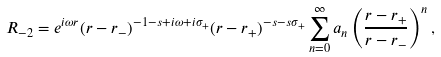<formula> <loc_0><loc_0><loc_500><loc_500>R _ { - 2 } = e ^ { i \omega r } ( r - r _ { - } ) ^ { - 1 - s + i \omega + i \sigma _ { + } } ( r - r _ { + } ) ^ { - s - s \sigma _ { + } } \sum ^ { \infty } _ { n = 0 } a _ { n } \left ( \frac { r - r _ { + } } { r - r _ { - } } \right ) ^ { n } ,</formula> 